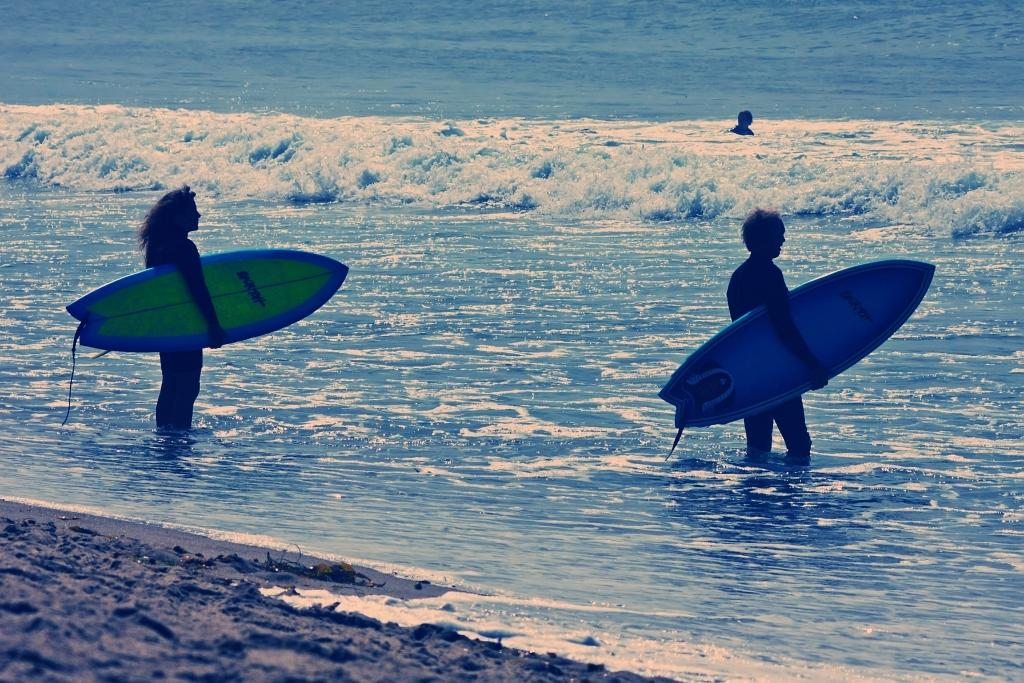How many people are in the image? There are three people in the image. What are two of the people holding? Two of the people are holding surfboards. Where are the two people with surfboards located? The two people with surfboards are standing in the sea. What can be seen on the ground in the image? There are objects on the ground in the image. Can you see any snails crawling on the surfboards in the image? There are no snails visible in the image, and they are not mentioned in the provided facts. 